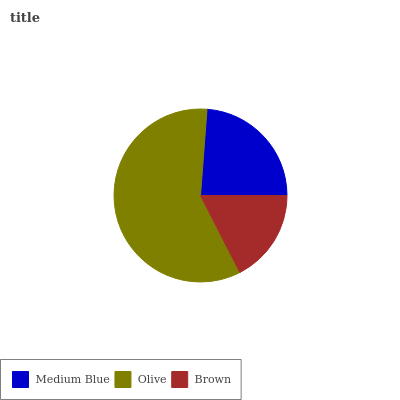Is Brown the minimum?
Answer yes or no. Yes. Is Olive the maximum?
Answer yes or no. Yes. Is Olive the minimum?
Answer yes or no. No. Is Brown the maximum?
Answer yes or no. No. Is Olive greater than Brown?
Answer yes or no. Yes. Is Brown less than Olive?
Answer yes or no. Yes. Is Brown greater than Olive?
Answer yes or no. No. Is Olive less than Brown?
Answer yes or no. No. Is Medium Blue the high median?
Answer yes or no. Yes. Is Medium Blue the low median?
Answer yes or no. Yes. Is Olive the high median?
Answer yes or no. No. Is Brown the low median?
Answer yes or no. No. 